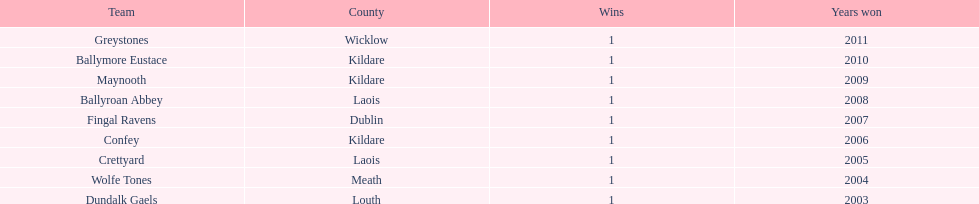Which team secured the title preceding ballyroan abbey in 2008? Fingal Ravens. 